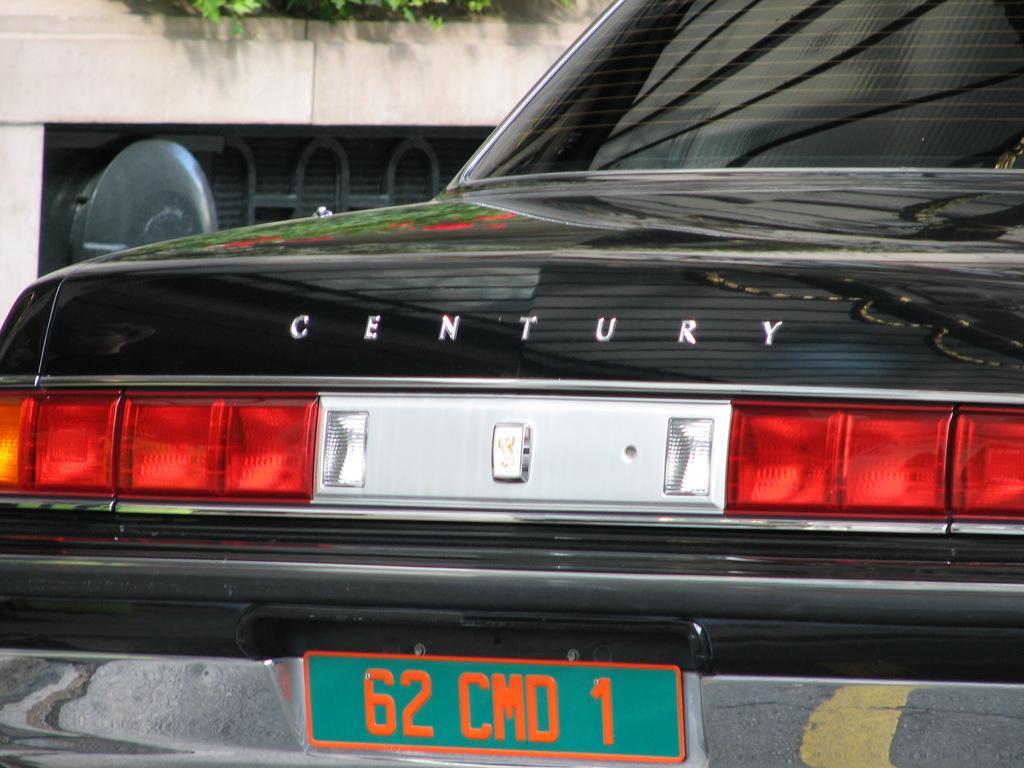How would you summarize this image in a sentence or two? In this image we can see the back part of a car, behind that there is a building and plants. 